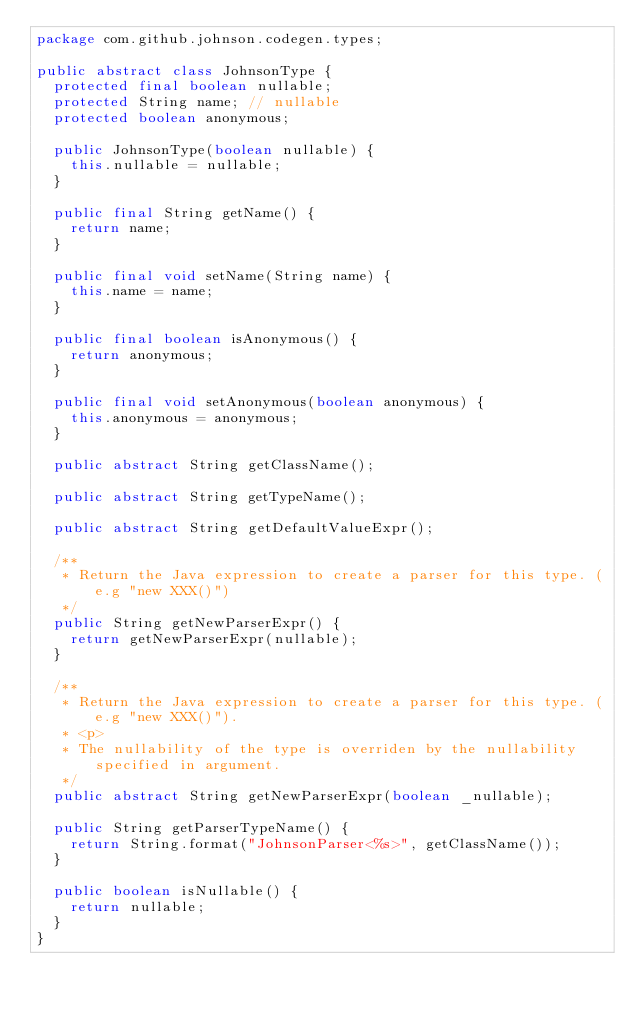<code> <loc_0><loc_0><loc_500><loc_500><_Java_>package com.github.johnson.codegen.types;

public abstract class JohnsonType {
	protected final boolean nullable;
	protected String name; // nullable
	protected boolean anonymous;

	public JohnsonType(boolean nullable) {
		this.nullable = nullable;
	}

	public final String getName() {
		return name;
	}

	public final void setName(String name) {
		this.name = name;
	}

	public final boolean isAnonymous() {
		return anonymous;
	}

	public final void setAnonymous(boolean anonymous) {
		this.anonymous = anonymous;
	}

	public abstract String getClassName();

	public abstract String getTypeName();

	public abstract String getDefaultValueExpr();

	/**
	 * Return the Java expression to create a parser for this type. (e.g "new XXX()")
	 */
	public String getNewParserExpr() {
		return getNewParserExpr(nullable);
	}

	/**
	 * Return the Java expression to create a parser for this type. (e.g "new XXX()").
	 * <p>
	 * The nullability of the type is overriden by the nullability specified in argument.
	 */
	public abstract String getNewParserExpr(boolean _nullable);

	public String getParserTypeName() {
		return String.format("JohnsonParser<%s>", getClassName());
	}

	public boolean isNullable() {
		return nullable;
	}
}</code> 